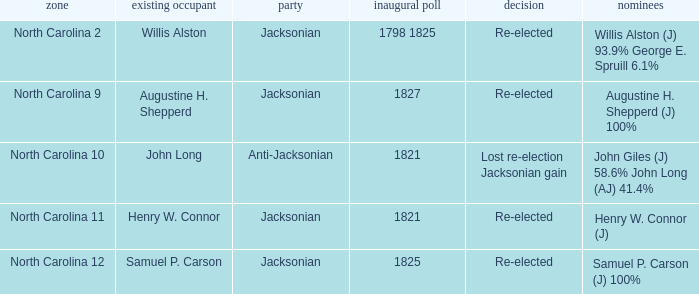Name the result for first elected being 1798 1825 Re-elected. 